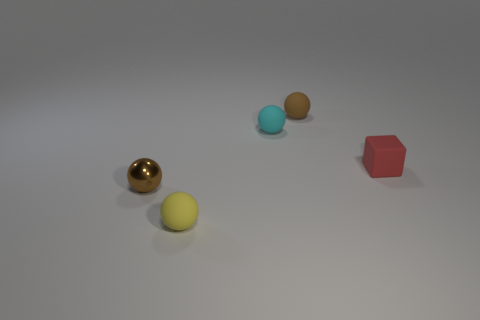Subtract all cyan cubes. Subtract all green spheres. How many cubes are left? 1 Add 5 gray rubber blocks. How many objects exist? 10 Subtract all spheres. How many objects are left? 1 Subtract 1 brown balls. How many objects are left? 4 Subtract all brown matte objects. Subtract all yellow objects. How many objects are left? 3 Add 3 small yellow objects. How many small yellow objects are left? 4 Add 3 green metal blocks. How many green metal blocks exist? 3 